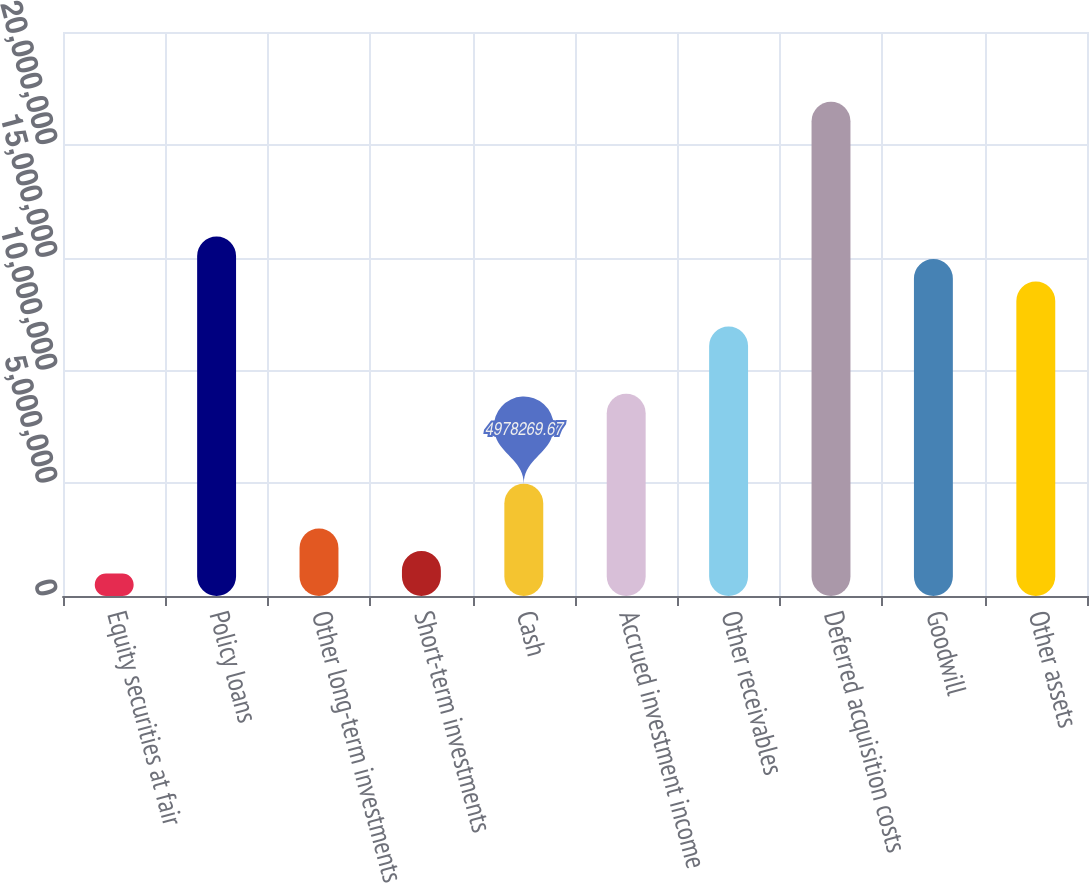Convert chart. <chart><loc_0><loc_0><loc_500><loc_500><bar_chart><fcel>Equity securities at fair<fcel>Policy loans<fcel>Other long-term investments<fcel>Short-term investments<fcel>Cash<fcel>Accrued investment income<fcel>Other receivables<fcel>Deferred acquisition costs<fcel>Goodwill<fcel>Other assets<nl><fcel>995656<fcel>1.59305e+07<fcel>2.98696e+06<fcel>1.99131e+06<fcel>4.97827e+06<fcel>8.96088e+06<fcel>1.19478e+07<fcel>2.19044e+07<fcel>1.49348e+07<fcel>1.39392e+07<nl></chart> 